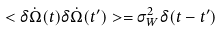<formula> <loc_0><loc_0><loc_500><loc_500>< \delta \dot { \Omega } ( t ) \delta \dot { \Omega } ( t ^ { \prime } ) > = \sigma _ { W } ^ { 2 } \delta ( t - t ^ { \prime } )</formula> 